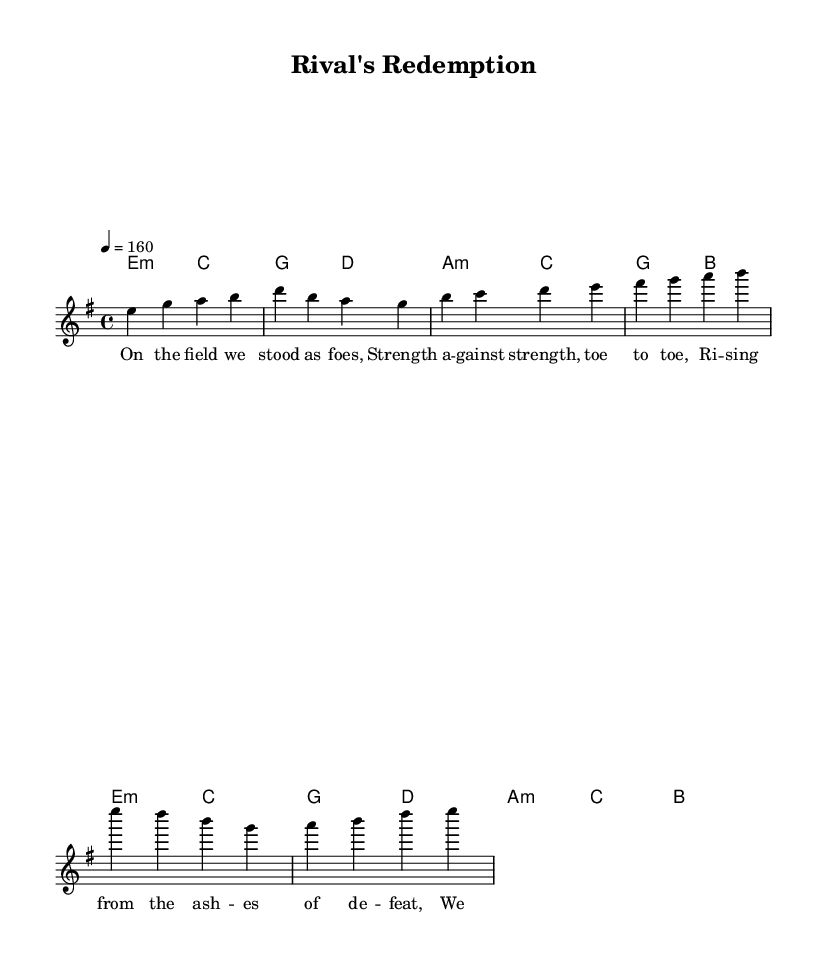What is the key signature of this music? The key signature is E minor, which has one sharp (F#) indicated at the beginning of the staff.
Answer: E minor What is the time signature of this piece? The time signature is indicated as 4/4, meaning there are four beats in each measure.
Answer: 4/4 What is the tempo marking for this piece? The tempo marking is specified as 4 = 160, which indicates the number of beats per minute in the performance.
Answer: 160 How many measures are in the verse section? The verse section contains 2 measures, as shown by the grouping of notes before transitioning to the pre-chorus.
Answer: 2 What is the main theme of the lyrics? The main theme emphasizes overcoming rivalry and gathering strength from past struggles, as indicated in both the verse and chorus.
Answer: Overcoming rivalry What type of harmony is used in the verse? The harmony in the verse consists of minor chords (E minor and C major), creating a somber yet powerful atmosphere typical in power metal.
Answer: Minor chords What is the structure of the song? The structure follows a common format: Verse, Pre-Chorus, and Chorus, each contributing to the building narrative of the lyrics.
Answer: Verse, Pre-Chorus, Chorus 